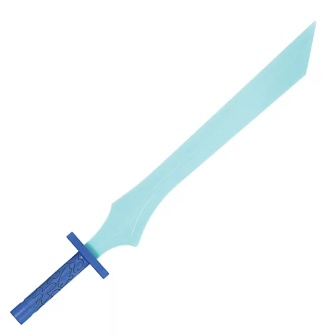Suppose this sword was part of a ritual. What kind of ritual would it be and what is its significance? This sword could play a central role in a binding ritual, a ceremony performed to seal or unseal powerful enchantments. The ritual might take place within a sacred grove, under the light of a full moon. Participants would gather around an ancient stone altar, and the sword's floral pommel would symbolize the bond between nature and magic. By tracing mystical patterns in the air with the blade, the wielder would activate or dispel protective charms, ensuring the balance between light and dark forces in the realm. 